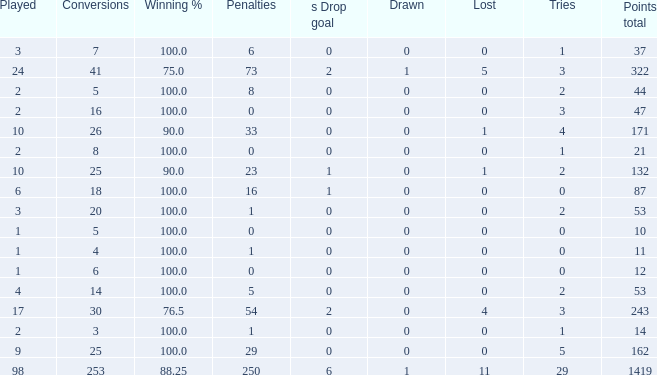How many ties did he have when he had 1 penalties and more than 20 conversions? None. 